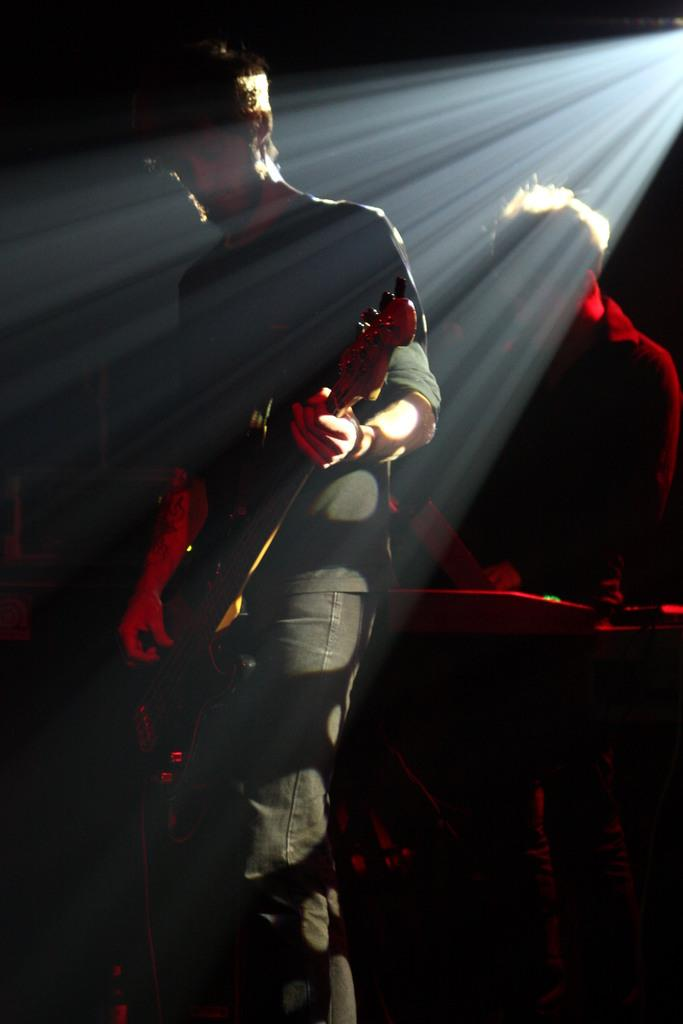How many people are in the image? There are two persons in the image. What are the persons holding in the image? The persons are holding musical instruments. What position are the persons in the image? The persons are standing. What type of robin can be seen in the image? There is no robin present in the image; it features two persons holding musical instruments while standing. 